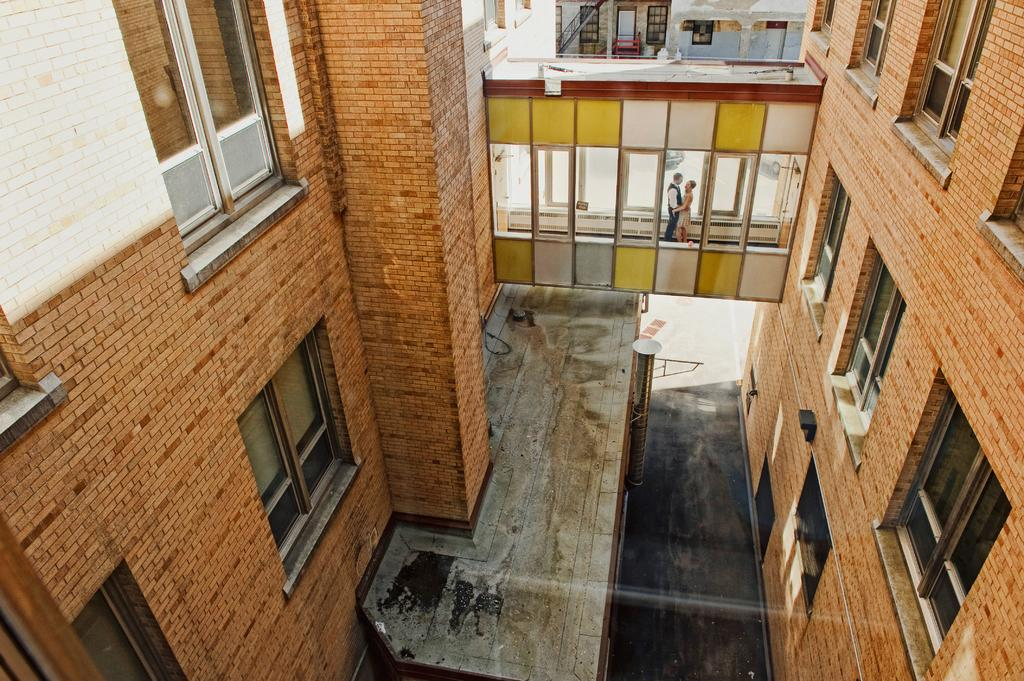What type of building is in the image? There is a brown building in the image. What features can be seen on the building? The building has windows. What structure is also present in the image? There is a bridge in the image. Who or what can be seen on the bridge? There are people on the bridge. What else can be seen in the background of the image? There is another building visible in the background. What type of insurance policy do the people on the bridge have? There is no information about insurance policies in the image; it only shows a brown building, a bridge, and people on the bridge. 